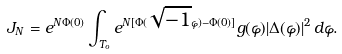Convert formula to latex. <formula><loc_0><loc_0><loc_500><loc_500>J _ { N } = e ^ { N \Phi ( 0 ) } \int _ { T _ { o } } e ^ { N [ \Phi ( \sqrt { - 1 } \varphi ) - \Phi ( 0 ) ] } g ( \varphi ) | \Delta ( \varphi ) | ^ { 2 } \, d \varphi .</formula> 